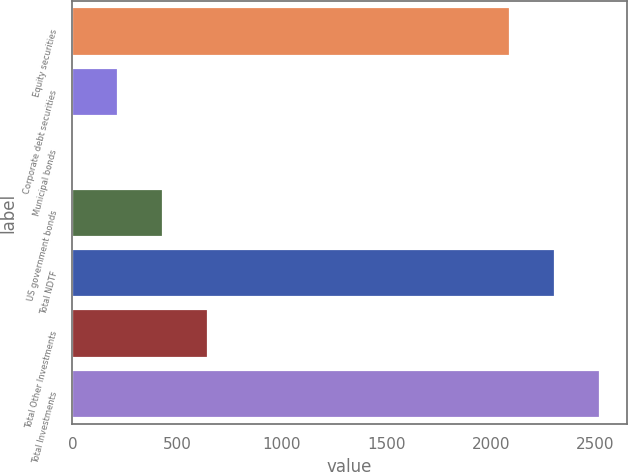Convert chart. <chart><loc_0><loc_0><loc_500><loc_500><bar_chart><fcel>Equity securities<fcel>Corporate debt securities<fcel>Municipal bonds<fcel>US government bonds<fcel>Total NDTF<fcel>Total Other Investments<fcel>Total Investments<nl><fcel>2092<fcel>218.3<fcel>3<fcel>433.6<fcel>2307.3<fcel>648.9<fcel>2522.6<nl></chart> 